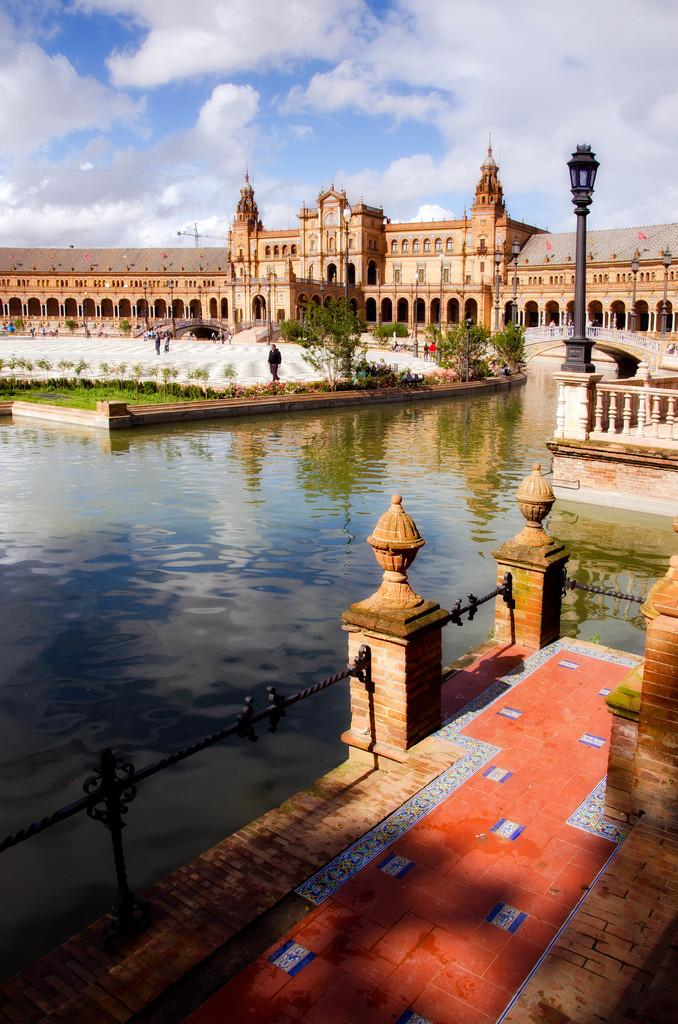What can be seen in the background of the image? There is a sky with clouds in the background of the image. What type of structure is present in the image? There is a castle in the image. What natural elements can be seen in the image? There is water, grass, and trees visible in the image. What architectural features are present on the right side of the image? There is a light pole, a railing, and a wall on the right side of the image. Are there any people in the image? Yes, there are people in the image. What type of hole can be seen in the image? There is no hole present in the image. What type of support is holding up the castle in the image? The image does not show any visible supports for the castle; it appears to be a self-standing structure. 